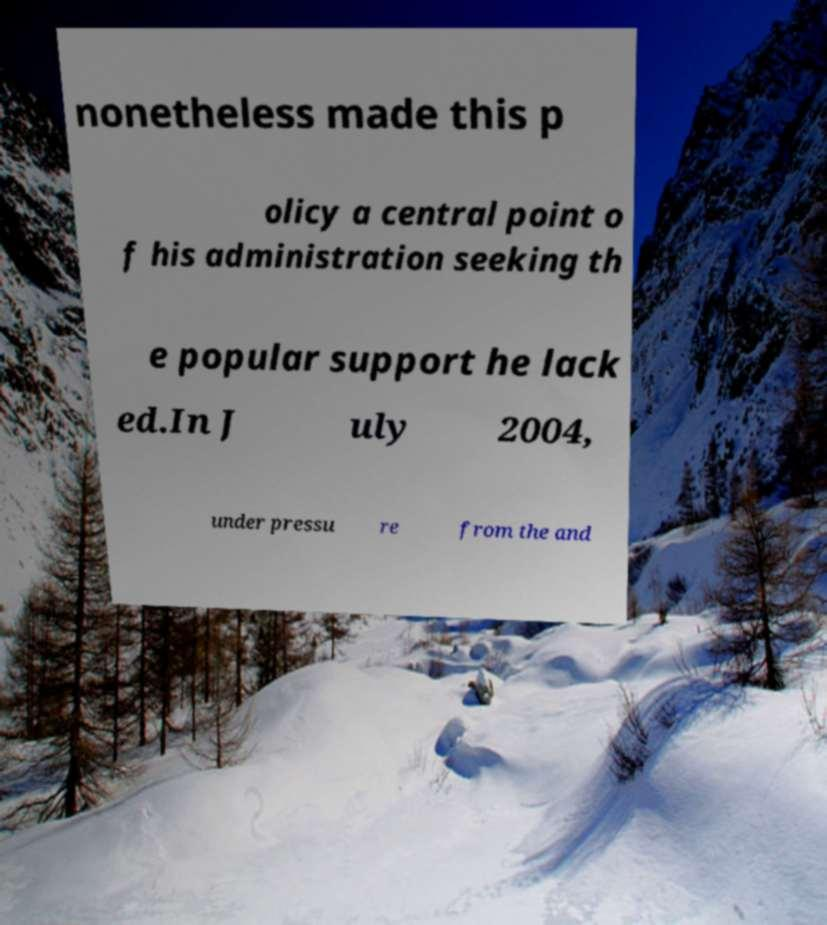Please read and relay the text visible in this image. What does it say? nonetheless made this p olicy a central point o f his administration seeking th e popular support he lack ed.In J uly 2004, under pressu re from the and 